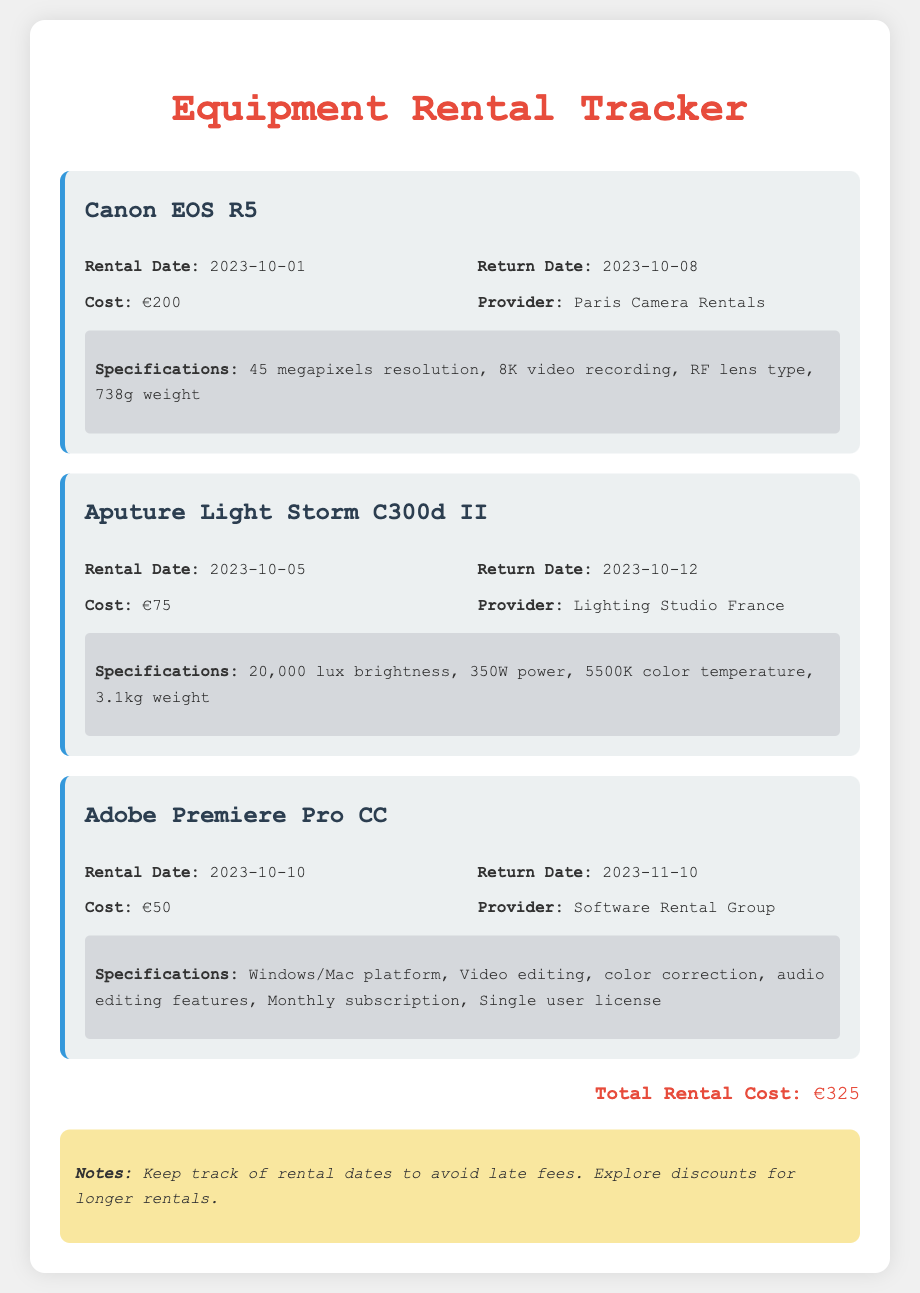What is the rental cost for the Canon EOS R5? The rental cost for the Canon EOS R5 is stated directly in the document.
Answer: €200 When is the return date for the Aputure Light Storm C300d II? The return date is specified in the rental details for the Aputure Light Storm C300d II section.
Answer: 2023-10-12 What is the total rental cost? The total rental cost is calculated and presented at the bottom of the document.
Answer: €325 How many megapixels does the Canon EOS R5 have? The specifications for the Canon EOS R5 include the megapixels resolution directly mentioned in the document.
Answer: 45 megapixels What is the provider for Adobe Premiere Pro CC? The provider for Adobe Premiere Pro CC is specifically mentioned in the rental details section.
Answer: Software Rental Group Which equipment has a rental date on October 10, 2023? The rental date for equipment is listed, and this specific date corresponds to one piece mentioned in the document.
Answer: Adobe Premiere Pro CC What is the weight of the Aputure Light Storm C300d II? The weight of the Aputure Light Storm C300d II is explicitly stated in the specifications section.
Answer: 3.1kg What kind of subscription is required for Adobe Premiere Pro CC? The specifications provide the type of subscription associated with Adobe Premiere Pro CC.
Answer: Monthly subscription 